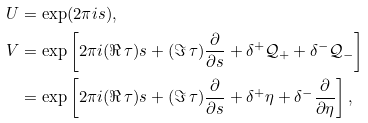<formula> <loc_0><loc_0><loc_500><loc_500>U & = \exp ( 2 \pi i s ) , \\ V & = \exp \left [ 2 \pi i ( \Re \, \tau ) s + ( \Im \, \tau ) \frac { \partial } { \partial s } + \delta ^ { + } \mathcal { Q } _ { + } + \delta ^ { - } \mathcal { Q } _ { - } \right ] \\ & = \exp \left [ 2 \pi i ( \Re \, \tau ) s + ( \Im \, \tau ) \frac { \partial } { \partial s } + \delta ^ { + } \eta + \delta ^ { - } \frac { \partial } { \partial \eta } \right ] ,</formula> 